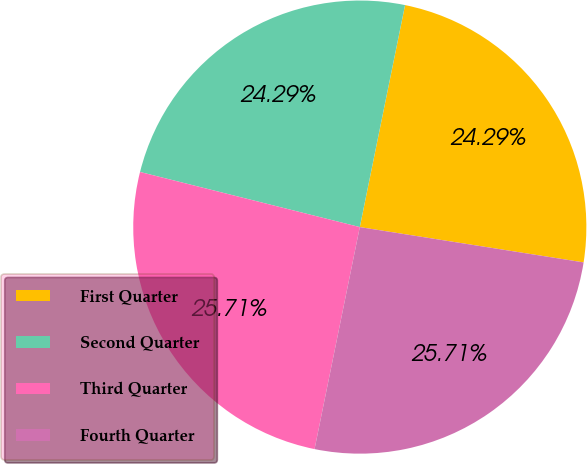Convert chart to OTSL. <chart><loc_0><loc_0><loc_500><loc_500><pie_chart><fcel>First Quarter<fcel>Second Quarter<fcel>Third Quarter<fcel>Fourth Quarter<nl><fcel>24.29%<fcel>24.29%<fcel>25.71%<fcel>25.71%<nl></chart> 